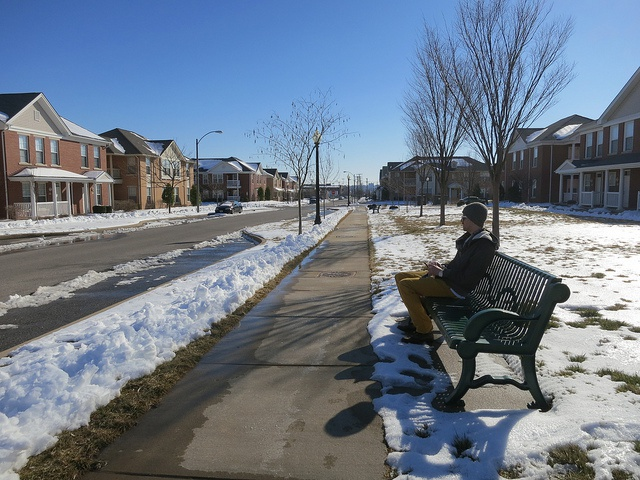Describe the objects in this image and their specific colors. I can see bench in blue, black, gray, darkgray, and purple tones, people in blue, black, gray, and darkgray tones, car in blue, black, gray, and darkgray tones, car in blue, black, and gray tones, and bench in blue, black, gray, and purple tones in this image. 